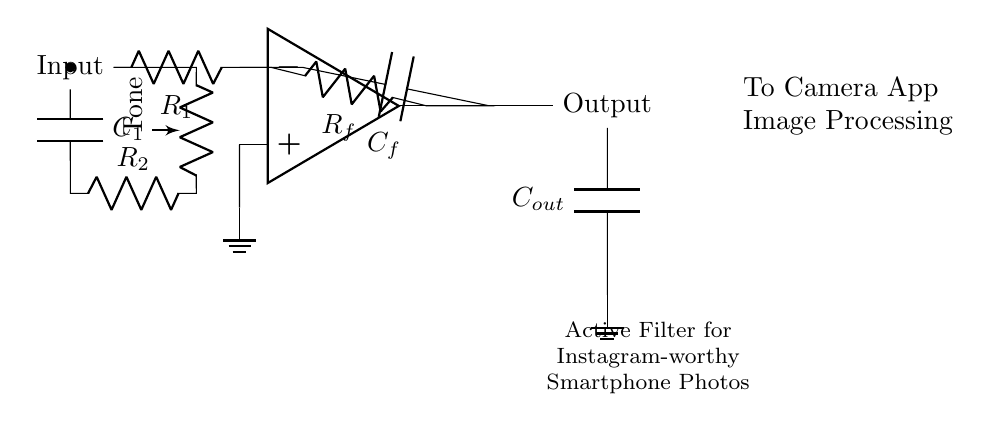What type of op-amp is used here? The symbol for an operational amplifier is displayed in the diagram, indicating this circuit uses a standard op-amp configuration.
Answer: Operational amplifier What does C_f stand for? In the circuit diagram, C_f is shown as a capacitor connected to the output of the op-amp. The label indicates it is the feedback capacitor.
Answer: Feedback capacitor What component adjusts the tone? The potentiometer labeled "Tone" is used for adjusting the tone in the circuit by varying resistance.
Answer: Potentiometer What is the purpose of R_f? The resistor R_f is connected in the feedback loop of the op-amp, which influences gain and thereby affects tone clarity.
Answer: Influence gain Explain how the input signal is processed. The input signal enters through C_1 into an RC network created with R_2 and the tone potentiometer, allowing for frequency filtering and tone adjustments before reaching the op-amp for amplification.
Answer: Frequency filtering How many capacitors are in the circuit? The diagram shows three capacitors: C_1, C_f, and C_out.
Answer: Three capacitors Which component connects to the camera app? The output node of the circuit, labeled as "Output", connects directly to the camera app for image processing.
Answer: Output 